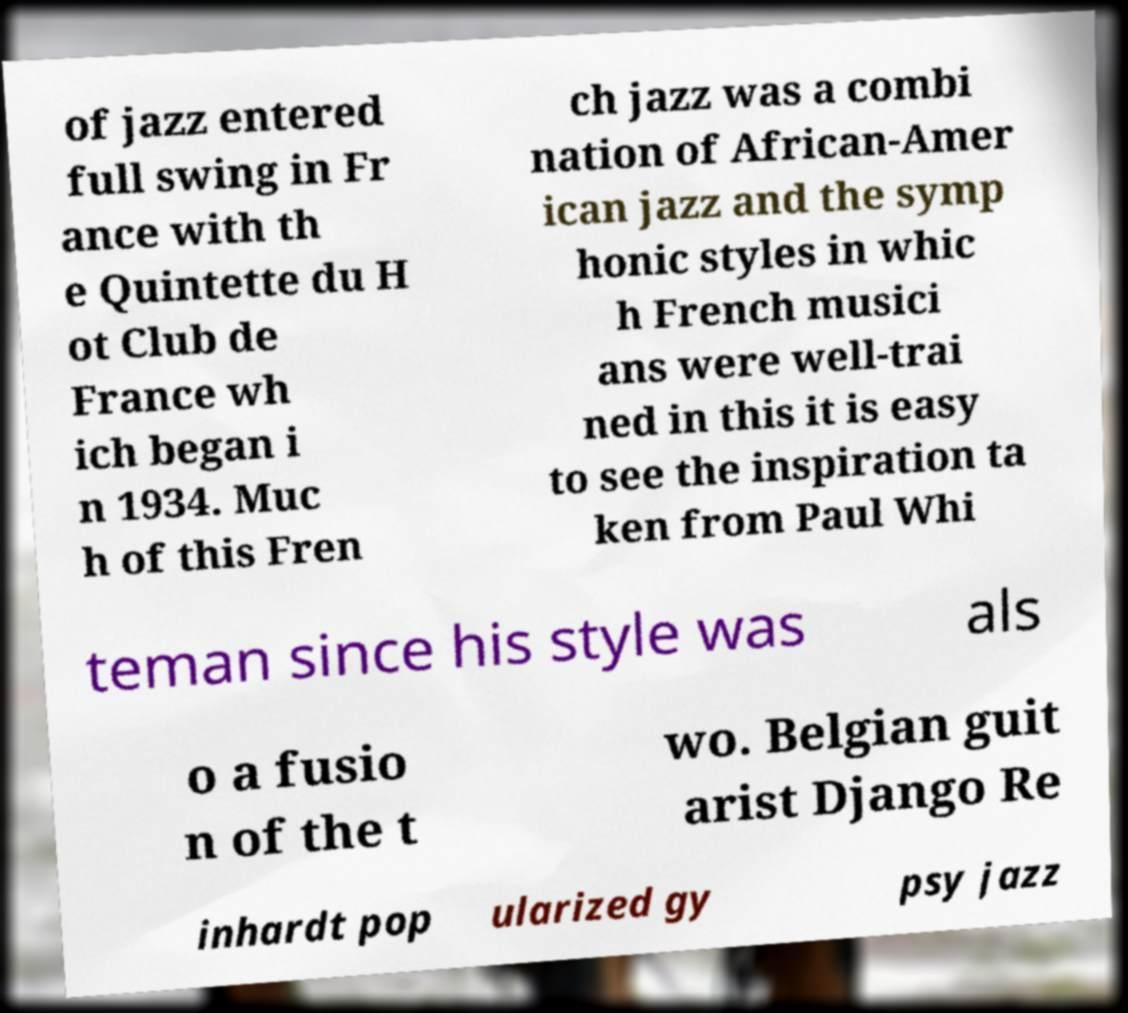Could you extract and type out the text from this image? of jazz entered full swing in Fr ance with th e Quintette du H ot Club de France wh ich began i n 1934. Muc h of this Fren ch jazz was a combi nation of African-Amer ican jazz and the symp honic styles in whic h French musici ans were well-trai ned in this it is easy to see the inspiration ta ken from Paul Whi teman since his style was als o a fusio n of the t wo. Belgian guit arist Django Re inhardt pop ularized gy psy jazz 